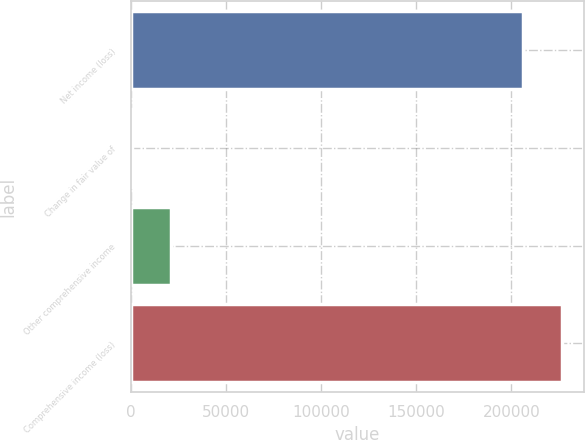Convert chart. <chart><loc_0><loc_0><loc_500><loc_500><bar_chart><fcel>Net income (loss)<fcel>Change in fair value of<fcel>Other comprehensive income<fcel>Comprehensive income (loss)<nl><fcel>206145<fcel>314<fcel>20928.5<fcel>226760<nl></chart> 